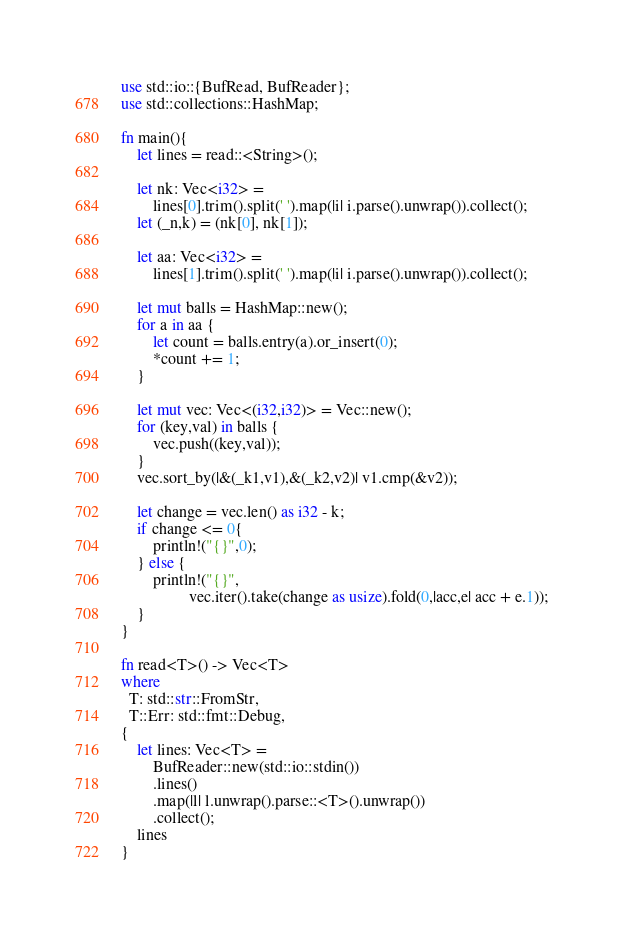Convert code to text. <code><loc_0><loc_0><loc_500><loc_500><_Rust_>use std::io::{BufRead, BufReader};
use std::collections::HashMap;

fn main(){
    let lines = read::<String>();

    let nk: Vec<i32> =
        lines[0].trim().split(' ').map(|i| i.parse().unwrap()).collect();
    let (_n,k) = (nk[0], nk[1]);

    let aa: Vec<i32> = 
        lines[1].trim().split(' ').map(|i| i.parse().unwrap()).collect();

    let mut balls = HashMap::new();
    for a in aa {
        let count = balls.entry(a).or_insert(0);
        *count += 1;
    }

    let mut vec: Vec<(i32,i32)> = Vec::new();
    for (key,val) in balls {
        vec.push((key,val));
    }
    vec.sort_by(|&(_k1,v1),&(_k2,v2)| v1.cmp(&v2));

    let change = vec.len() as i32 - k;
    if change <= 0{
        println!("{}",0);
    } else {
        println!("{}",
                 vec.iter().take(change as usize).fold(0,|acc,e| acc + e.1));
    }
}

fn read<T>() -> Vec<T>
where
  T: std::str::FromStr,
  T::Err: std::fmt::Debug,
{
    let lines: Vec<T> =
        BufReader::new(std::io::stdin())
        .lines()
        .map(|l| l.unwrap().parse::<T>().unwrap())
        .collect();
    lines
}
</code> 